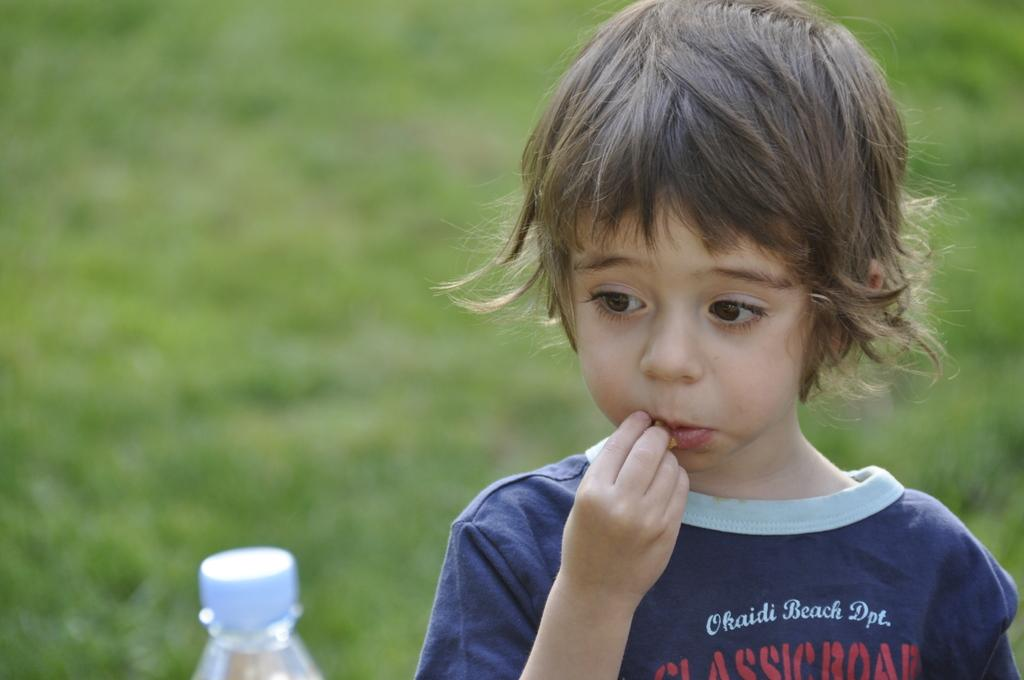Who is the main subject in the image? There is a little boy in the boy in the image. What can be said about the boy's hair color? The boy's hair is brown. Where is the boy standing? The boy is standing on the grass. What is the boy doing in the image? The boy is eating something. What object is in front of the boy? There is a bottle in front of the boy. How many mice are playing with the bottle in the image? There are no mice present in the image, and therefore no such activity can be observed. Is the dog lying on a quilt in the image? There is no dog or quilt present in the image. 